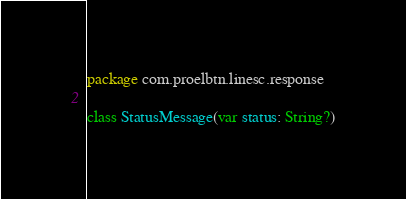<code> <loc_0><loc_0><loc_500><loc_500><_Kotlin_>package com.proelbtn.linesc.response

class StatusMessage(var status: String?)
</code> 